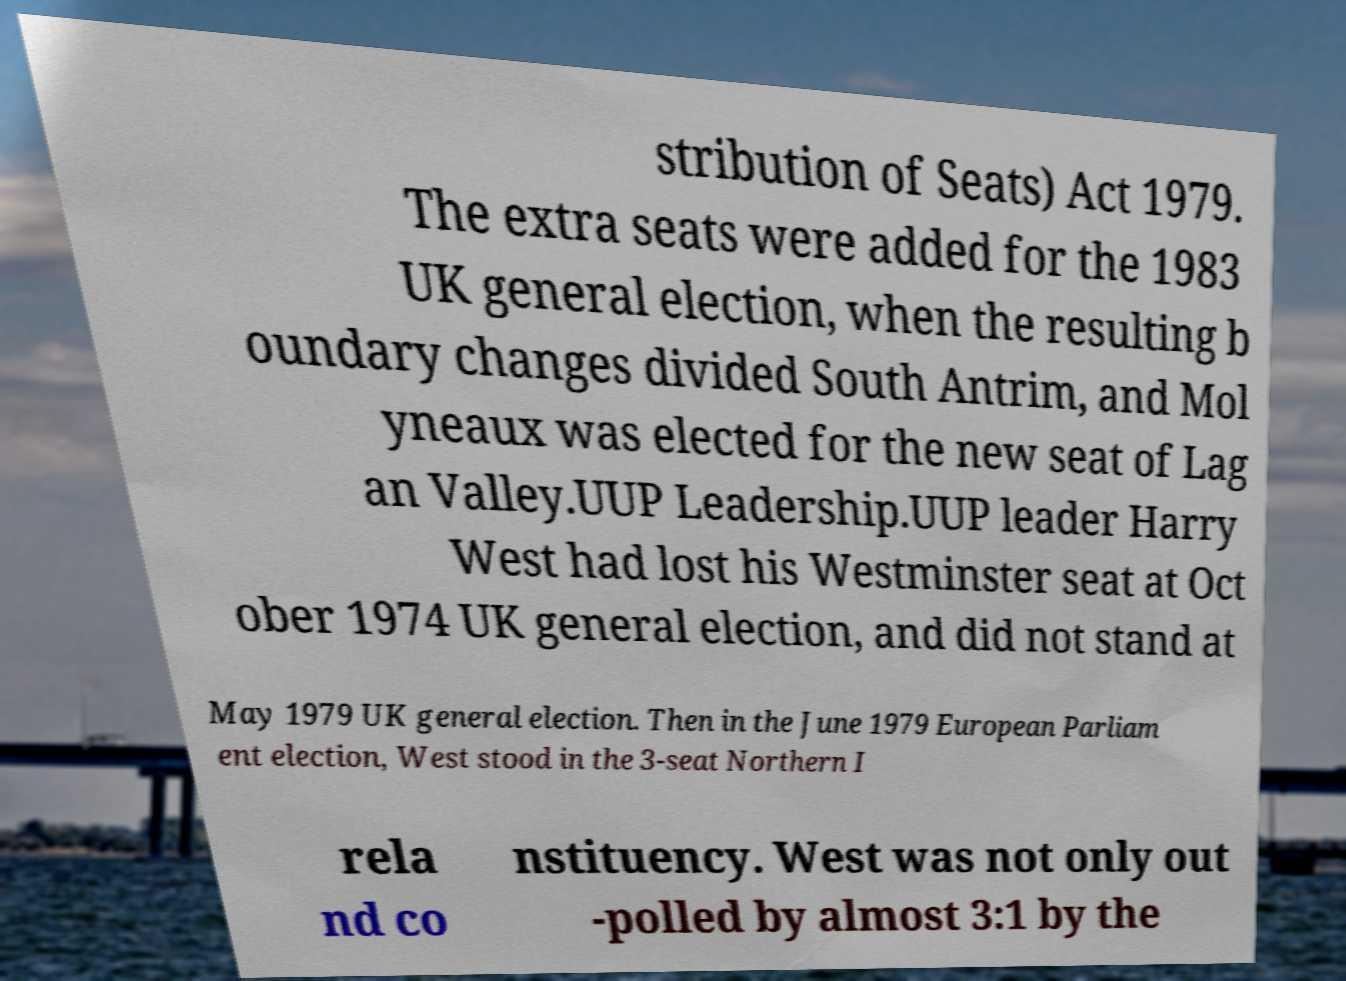Please read and relay the text visible in this image. What does it say? stribution of Seats) Act 1979. The extra seats were added for the 1983 UK general election, when the resulting b oundary changes divided South Antrim, and Mol yneaux was elected for the new seat of Lag an Valley.UUP Leadership.UUP leader Harry West had lost his Westminster seat at Oct ober 1974 UK general election, and did not stand at May 1979 UK general election. Then in the June 1979 European Parliam ent election, West stood in the 3-seat Northern I rela nd co nstituency. West was not only out -polled by almost 3:1 by the 